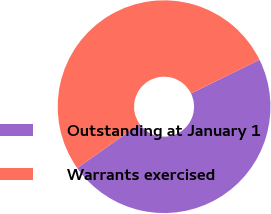Convert chart to OTSL. <chart><loc_0><loc_0><loc_500><loc_500><pie_chart><fcel>Outstanding at January 1<fcel>Warrants exercised<nl><fcel>47.49%<fcel>52.51%<nl></chart> 